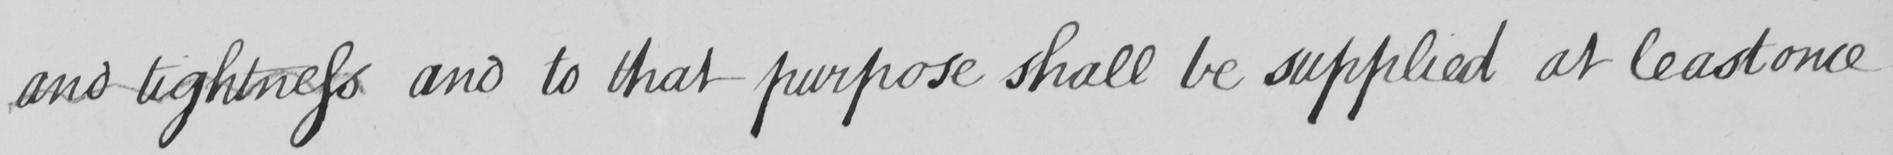What is written in this line of handwriting? and tightness and to that purpose shall be supplied at least once 